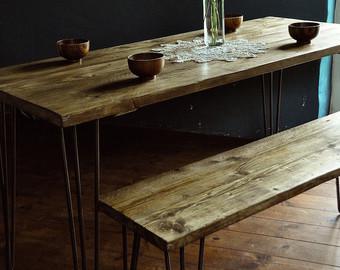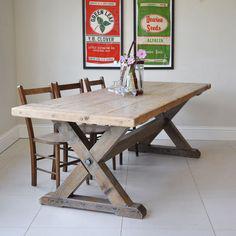The first image is the image on the left, the second image is the image on the right. Considering the images on both sides, is "There are four chairs in the image on the right." valid? Answer yes or no. No. 